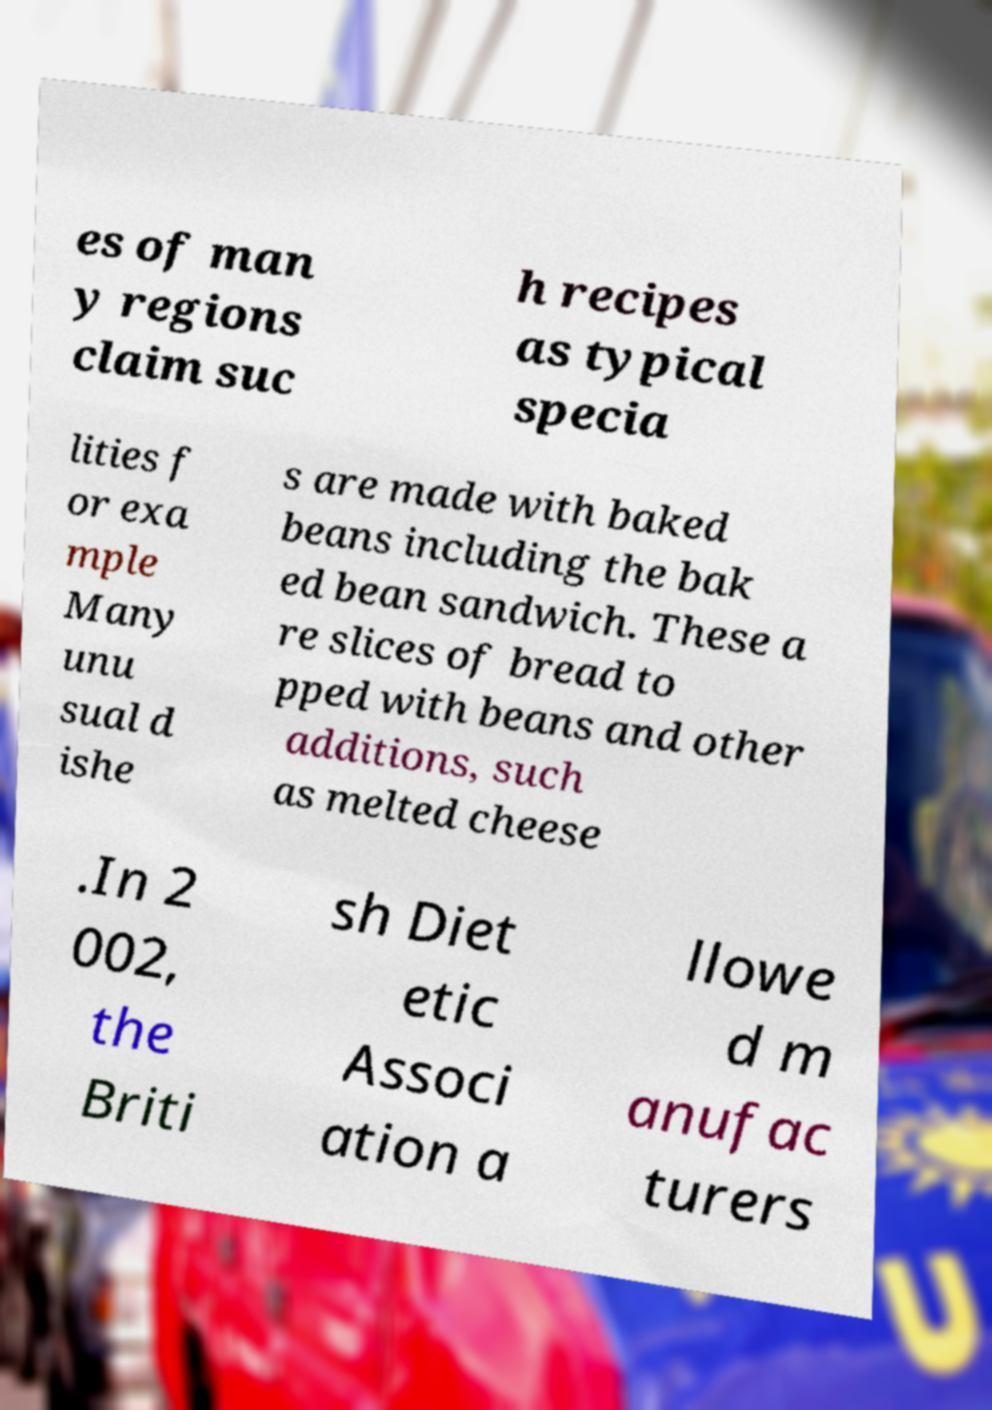What messages or text are displayed in this image? I need them in a readable, typed format. es of man y regions claim suc h recipes as typical specia lities f or exa mple Many unu sual d ishe s are made with baked beans including the bak ed bean sandwich. These a re slices of bread to pped with beans and other additions, such as melted cheese .In 2 002, the Briti sh Diet etic Associ ation a llowe d m anufac turers 